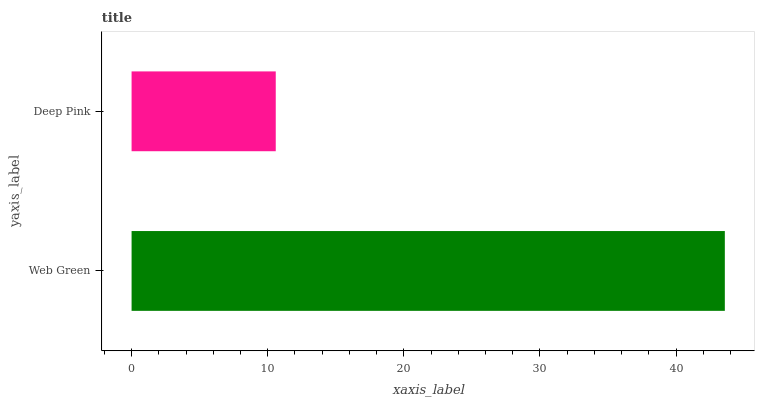Is Deep Pink the minimum?
Answer yes or no. Yes. Is Web Green the maximum?
Answer yes or no. Yes. Is Deep Pink the maximum?
Answer yes or no. No. Is Web Green greater than Deep Pink?
Answer yes or no. Yes. Is Deep Pink less than Web Green?
Answer yes or no. Yes. Is Deep Pink greater than Web Green?
Answer yes or no. No. Is Web Green less than Deep Pink?
Answer yes or no. No. Is Web Green the high median?
Answer yes or no. Yes. Is Deep Pink the low median?
Answer yes or no. Yes. Is Deep Pink the high median?
Answer yes or no. No. Is Web Green the low median?
Answer yes or no. No. 